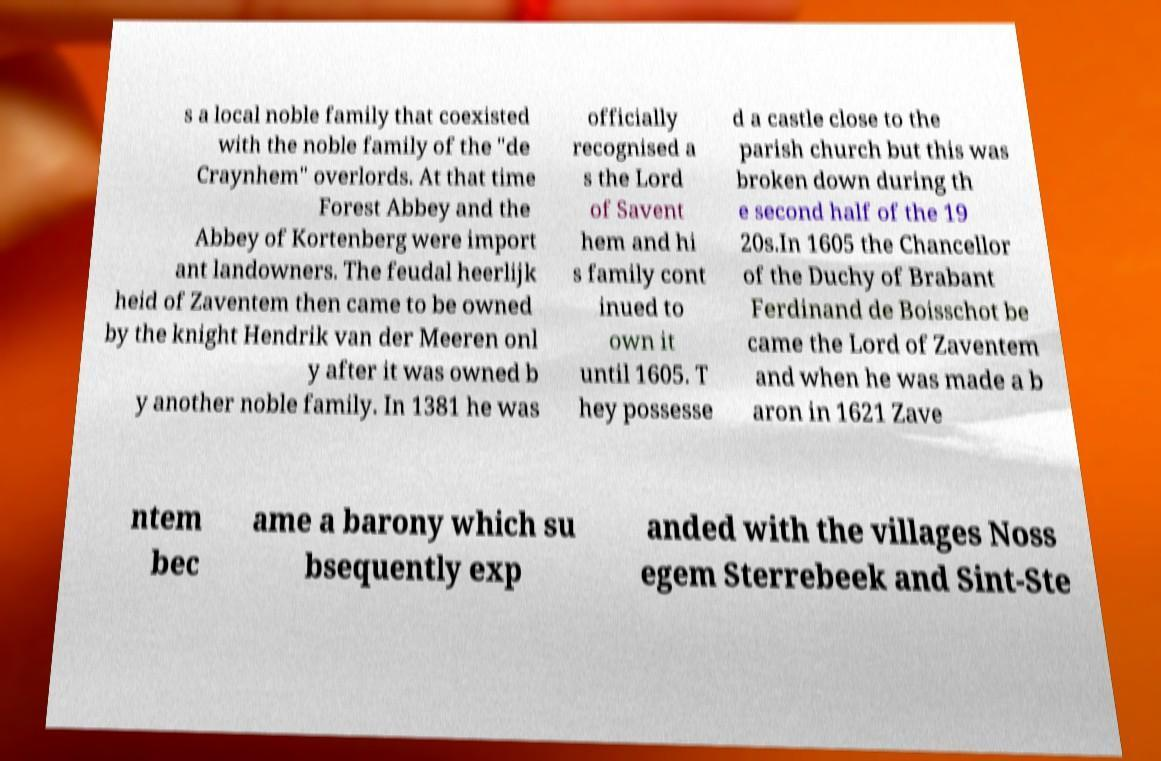For documentation purposes, I need the text within this image transcribed. Could you provide that? s a local noble family that coexisted with the noble family of the "de Craynhem" overlords. At that time Forest Abbey and the Abbey of Kortenberg were import ant landowners. The feudal heerlijk heid of Zaventem then came to be owned by the knight Hendrik van der Meeren onl y after it was owned b y another noble family. In 1381 he was officially recognised a s the Lord of Savent hem and hi s family cont inued to own it until 1605. T hey possesse d a castle close to the parish church but this was broken down during th e second half of the 19 20s.In 1605 the Chancellor of the Duchy of Brabant Ferdinand de Boisschot be came the Lord of Zaventem and when he was made a b aron in 1621 Zave ntem bec ame a barony which su bsequently exp anded with the villages Noss egem Sterrebeek and Sint-Ste 